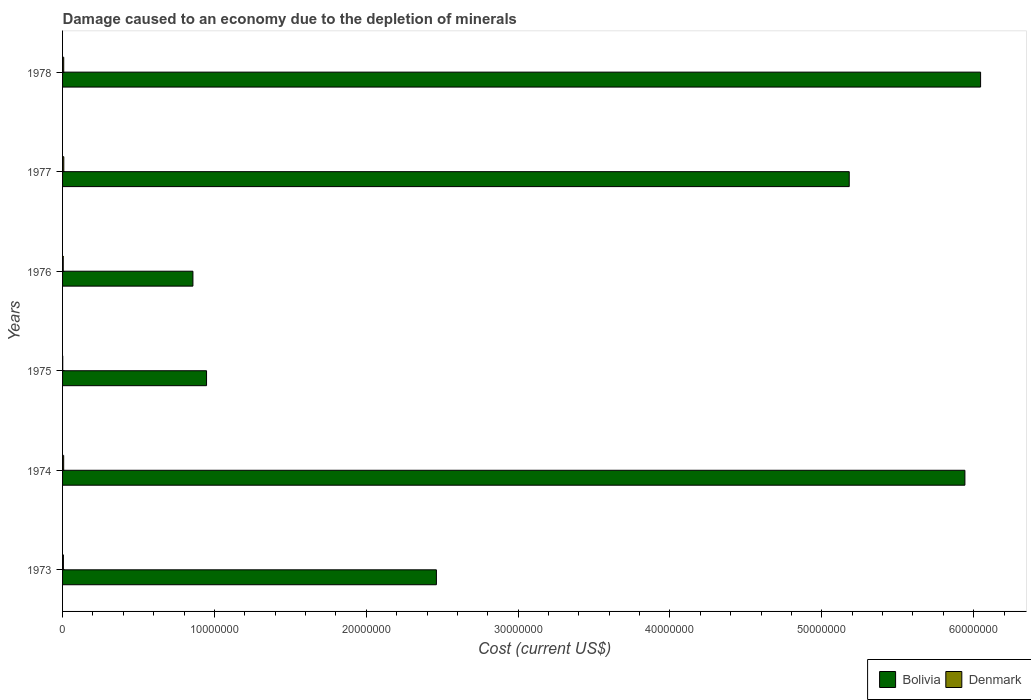How many different coloured bars are there?
Offer a very short reply. 2. How many bars are there on the 5th tick from the top?
Give a very brief answer. 2. What is the label of the 6th group of bars from the top?
Offer a terse response. 1973. What is the cost of damage caused due to the depletion of minerals in Denmark in 1973?
Offer a terse response. 5.65e+04. Across all years, what is the maximum cost of damage caused due to the depletion of minerals in Bolivia?
Ensure brevity in your answer.  6.05e+07. Across all years, what is the minimum cost of damage caused due to the depletion of minerals in Bolivia?
Make the answer very short. 8.58e+06. In which year was the cost of damage caused due to the depletion of minerals in Denmark maximum?
Offer a very short reply. 1977. In which year was the cost of damage caused due to the depletion of minerals in Bolivia minimum?
Ensure brevity in your answer.  1976. What is the total cost of damage caused due to the depletion of minerals in Bolivia in the graph?
Offer a very short reply. 2.14e+08. What is the difference between the cost of damage caused due to the depletion of minerals in Bolivia in 1976 and that in 1977?
Provide a succinct answer. -4.32e+07. What is the difference between the cost of damage caused due to the depletion of minerals in Bolivia in 1978 and the cost of damage caused due to the depletion of minerals in Denmark in 1976?
Give a very brief answer. 6.04e+07. What is the average cost of damage caused due to the depletion of minerals in Denmark per year?
Offer a terse response. 5.70e+04. In the year 1978, what is the difference between the cost of damage caused due to the depletion of minerals in Bolivia and cost of damage caused due to the depletion of minerals in Denmark?
Offer a very short reply. 6.04e+07. In how many years, is the cost of damage caused due to the depletion of minerals in Denmark greater than 34000000 US$?
Your response must be concise. 0. What is the ratio of the cost of damage caused due to the depletion of minerals in Bolivia in 1973 to that in 1975?
Provide a short and direct response. 2.6. Is the cost of damage caused due to the depletion of minerals in Bolivia in 1976 less than that in 1977?
Your response must be concise. Yes. What is the difference between the highest and the second highest cost of damage caused due to the depletion of minerals in Bolivia?
Offer a terse response. 1.03e+06. What is the difference between the highest and the lowest cost of damage caused due to the depletion of minerals in Denmark?
Your answer should be compact. 7.11e+04. Is the sum of the cost of damage caused due to the depletion of minerals in Bolivia in 1974 and 1975 greater than the maximum cost of damage caused due to the depletion of minerals in Denmark across all years?
Your answer should be very brief. Yes. What does the 1st bar from the top in 1973 represents?
Keep it short and to the point. Denmark. What does the 2nd bar from the bottom in 1977 represents?
Make the answer very short. Denmark. How many years are there in the graph?
Your response must be concise. 6. Are the values on the major ticks of X-axis written in scientific E-notation?
Your answer should be compact. No. Does the graph contain any zero values?
Provide a succinct answer. No. Where does the legend appear in the graph?
Your response must be concise. Bottom right. How many legend labels are there?
Offer a very short reply. 2. What is the title of the graph?
Your answer should be compact. Damage caused to an economy due to the depletion of minerals. Does "Low income" appear as one of the legend labels in the graph?
Make the answer very short. No. What is the label or title of the X-axis?
Offer a terse response. Cost (current US$). What is the Cost (current US$) in Bolivia in 1973?
Your answer should be very brief. 2.46e+07. What is the Cost (current US$) of Denmark in 1973?
Give a very brief answer. 5.65e+04. What is the Cost (current US$) in Bolivia in 1974?
Ensure brevity in your answer.  5.94e+07. What is the Cost (current US$) of Denmark in 1974?
Your response must be concise. 7.27e+04. What is the Cost (current US$) of Bolivia in 1975?
Provide a short and direct response. 9.48e+06. What is the Cost (current US$) of Denmark in 1975?
Your response must be concise. 1.03e+04. What is the Cost (current US$) of Bolivia in 1976?
Your answer should be very brief. 8.58e+06. What is the Cost (current US$) in Denmark in 1976?
Ensure brevity in your answer.  4.48e+04. What is the Cost (current US$) in Bolivia in 1977?
Offer a very short reply. 5.18e+07. What is the Cost (current US$) of Denmark in 1977?
Offer a terse response. 8.14e+04. What is the Cost (current US$) in Bolivia in 1978?
Your response must be concise. 6.05e+07. What is the Cost (current US$) of Denmark in 1978?
Give a very brief answer. 7.64e+04. Across all years, what is the maximum Cost (current US$) in Bolivia?
Provide a short and direct response. 6.05e+07. Across all years, what is the maximum Cost (current US$) of Denmark?
Provide a short and direct response. 8.14e+04. Across all years, what is the minimum Cost (current US$) in Bolivia?
Give a very brief answer. 8.58e+06. Across all years, what is the minimum Cost (current US$) in Denmark?
Keep it short and to the point. 1.03e+04. What is the total Cost (current US$) of Bolivia in the graph?
Offer a very short reply. 2.14e+08. What is the total Cost (current US$) in Denmark in the graph?
Your answer should be compact. 3.42e+05. What is the difference between the Cost (current US$) of Bolivia in 1973 and that in 1974?
Provide a short and direct response. -3.48e+07. What is the difference between the Cost (current US$) in Denmark in 1973 and that in 1974?
Your answer should be very brief. -1.62e+04. What is the difference between the Cost (current US$) of Bolivia in 1973 and that in 1975?
Your answer should be very brief. 1.51e+07. What is the difference between the Cost (current US$) of Denmark in 1973 and that in 1975?
Your answer should be very brief. 4.62e+04. What is the difference between the Cost (current US$) in Bolivia in 1973 and that in 1976?
Ensure brevity in your answer.  1.60e+07. What is the difference between the Cost (current US$) in Denmark in 1973 and that in 1976?
Keep it short and to the point. 1.16e+04. What is the difference between the Cost (current US$) of Bolivia in 1973 and that in 1977?
Your answer should be very brief. -2.72e+07. What is the difference between the Cost (current US$) of Denmark in 1973 and that in 1977?
Your answer should be very brief. -2.49e+04. What is the difference between the Cost (current US$) of Bolivia in 1973 and that in 1978?
Your answer should be compact. -3.58e+07. What is the difference between the Cost (current US$) in Denmark in 1973 and that in 1978?
Ensure brevity in your answer.  -1.99e+04. What is the difference between the Cost (current US$) of Bolivia in 1974 and that in 1975?
Make the answer very short. 4.99e+07. What is the difference between the Cost (current US$) in Denmark in 1974 and that in 1975?
Your response must be concise. 6.24e+04. What is the difference between the Cost (current US$) in Bolivia in 1974 and that in 1976?
Give a very brief answer. 5.08e+07. What is the difference between the Cost (current US$) of Denmark in 1974 and that in 1976?
Provide a short and direct response. 2.78e+04. What is the difference between the Cost (current US$) of Bolivia in 1974 and that in 1977?
Your answer should be compact. 7.62e+06. What is the difference between the Cost (current US$) of Denmark in 1974 and that in 1977?
Provide a short and direct response. -8739.33. What is the difference between the Cost (current US$) of Bolivia in 1974 and that in 1978?
Provide a succinct answer. -1.03e+06. What is the difference between the Cost (current US$) in Denmark in 1974 and that in 1978?
Offer a very short reply. -3697.88. What is the difference between the Cost (current US$) in Bolivia in 1975 and that in 1976?
Your response must be concise. 8.97e+05. What is the difference between the Cost (current US$) in Denmark in 1975 and that in 1976?
Offer a terse response. -3.45e+04. What is the difference between the Cost (current US$) in Bolivia in 1975 and that in 1977?
Your answer should be very brief. -4.23e+07. What is the difference between the Cost (current US$) of Denmark in 1975 and that in 1977?
Your response must be concise. -7.11e+04. What is the difference between the Cost (current US$) of Bolivia in 1975 and that in 1978?
Your answer should be compact. -5.10e+07. What is the difference between the Cost (current US$) of Denmark in 1975 and that in 1978?
Your response must be concise. -6.61e+04. What is the difference between the Cost (current US$) in Bolivia in 1976 and that in 1977?
Offer a terse response. -4.32e+07. What is the difference between the Cost (current US$) of Denmark in 1976 and that in 1977?
Offer a terse response. -3.66e+04. What is the difference between the Cost (current US$) in Bolivia in 1976 and that in 1978?
Your answer should be compact. -5.19e+07. What is the difference between the Cost (current US$) in Denmark in 1976 and that in 1978?
Provide a short and direct response. -3.15e+04. What is the difference between the Cost (current US$) of Bolivia in 1977 and that in 1978?
Your response must be concise. -8.65e+06. What is the difference between the Cost (current US$) in Denmark in 1977 and that in 1978?
Keep it short and to the point. 5041.45. What is the difference between the Cost (current US$) of Bolivia in 1973 and the Cost (current US$) of Denmark in 1974?
Offer a very short reply. 2.45e+07. What is the difference between the Cost (current US$) of Bolivia in 1973 and the Cost (current US$) of Denmark in 1975?
Offer a very short reply. 2.46e+07. What is the difference between the Cost (current US$) of Bolivia in 1973 and the Cost (current US$) of Denmark in 1976?
Ensure brevity in your answer.  2.46e+07. What is the difference between the Cost (current US$) in Bolivia in 1973 and the Cost (current US$) in Denmark in 1977?
Ensure brevity in your answer.  2.45e+07. What is the difference between the Cost (current US$) in Bolivia in 1973 and the Cost (current US$) in Denmark in 1978?
Your response must be concise. 2.45e+07. What is the difference between the Cost (current US$) in Bolivia in 1974 and the Cost (current US$) in Denmark in 1975?
Provide a succinct answer. 5.94e+07. What is the difference between the Cost (current US$) in Bolivia in 1974 and the Cost (current US$) in Denmark in 1976?
Give a very brief answer. 5.94e+07. What is the difference between the Cost (current US$) in Bolivia in 1974 and the Cost (current US$) in Denmark in 1977?
Give a very brief answer. 5.93e+07. What is the difference between the Cost (current US$) in Bolivia in 1974 and the Cost (current US$) in Denmark in 1978?
Offer a very short reply. 5.93e+07. What is the difference between the Cost (current US$) of Bolivia in 1975 and the Cost (current US$) of Denmark in 1976?
Offer a terse response. 9.44e+06. What is the difference between the Cost (current US$) in Bolivia in 1975 and the Cost (current US$) in Denmark in 1977?
Keep it short and to the point. 9.40e+06. What is the difference between the Cost (current US$) in Bolivia in 1975 and the Cost (current US$) in Denmark in 1978?
Offer a very short reply. 9.41e+06. What is the difference between the Cost (current US$) in Bolivia in 1976 and the Cost (current US$) in Denmark in 1977?
Give a very brief answer. 8.50e+06. What is the difference between the Cost (current US$) of Bolivia in 1976 and the Cost (current US$) of Denmark in 1978?
Give a very brief answer. 8.51e+06. What is the difference between the Cost (current US$) in Bolivia in 1977 and the Cost (current US$) in Denmark in 1978?
Offer a very short reply. 5.17e+07. What is the average Cost (current US$) of Bolivia per year?
Provide a short and direct response. 3.57e+07. What is the average Cost (current US$) in Denmark per year?
Keep it short and to the point. 5.70e+04. In the year 1973, what is the difference between the Cost (current US$) of Bolivia and Cost (current US$) of Denmark?
Ensure brevity in your answer.  2.46e+07. In the year 1974, what is the difference between the Cost (current US$) of Bolivia and Cost (current US$) of Denmark?
Your answer should be compact. 5.93e+07. In the year 1975, what is the difference between the Cost (current US$) of Bolivia and Cost (current US$) of Denmark?
Your answer should be compact. 9.47e+06. In the year 1976, what is the difference between the Cost (current US$) in Bolivia and Cost (current US$) in Denmark?
Provide a short and direct response. 8.54e+06. In the year 1977, what is the difference between the Cost (current US$) of Bolivia and Cost (current US$) of Denmark?
Your answer should be compact. 5.17e+07. In the year 1978, what is the difference between the Cost (current US$) in Bolivia and Cost (current US$) in Denmark?
Ensure brevity in your answer.  6.04e+07. What is the ratio of the Cost (current US$) in Bolivia in 1973 to that in 1974?
Provide a short and direct response. 0.41. What is the ratio of the Cost (current US$) of Denmark in 1973 to that in 1974?
Your answer should be very brief. 0.78. What is the ratio of the Cost (current US$) in Bolivia in 1973 to that in 1975?
Provide a short and direct response. 2.6. What is the ratio of the Cost (current US$) of Denmark in 1973 to that in 1975?
Keep it short and to the point. 5.49. What is the ratio of the Cost (current US$) of Bolivia in 1973 to that in 1976?
Provide a short and direct response. 2.87. What is the ratio of the Cost (current US$) in Denmark in 1973 to that in 1976?
Your response must be concise. 1.26. What is the ratio of the Cost (current US$) of Bolivia in 1973 to that in 1977?
Give a very brief answer. 0.48. What is the ratio of the Cost (current US$) in Denmark in 1973 to that in 1977?
Ensure brevity in your answer.  0.69. What is the ratio of the Cost (current US$) in Bolivia in 1973 to that in 1978?
Offer a very short reply. 0.41. What is the ratio of the Cost (current US$) of Denmark in 1973 to that in 1978?
Your answer should be compact. 0.74. What is the ratio of the Cost (current US$) of Bolivia in 1974 to that in 1975?
Offer a very short reply. 6.27. What is the ratio of the Cost (current US$) of Denmark in 1974 to that in 1975?
Give a very brief answer. 7.06. What is the ratio of the Cost (current US$) of Bolivia in 1974 to that in 1976?
Your answer should be very brief. 6.92. What is the ratio of the Cost (current US$) of Denmark in 1974 to that in 1976?
Keep it short and to the point. 1.62. What is the ratio of the Cost (current US$) of Bolivia in 1974 to that in 1977?
Make the answer very short. 1.15. What is the ratio of the Cost (current US$) in Denmark in 1974 to that in 1977?
Offer a very short reply. 0.89. What is the ratio of the Cost (current US$) in Bolivia in 1974 to that in 1978?
Provide a succinct answer. 0.98. What is the ratio of the Cost (current US$) of Denmark in 1974 to that in 1978?
Offer a very short reply. 0.95. What is the ratio of the Cost (current US$) in Bolivia in 1975 to that in 1976?
Offer a terse response. 1.1. What is the ratio of the Cost (current US$) of Denmark in 1975 to that in 1976?
Make the answer very short. 0.23. What is the ratio of the Cost (current US$) of Bolivia in 1975 to that in 1977?
Provide a succinct answer. 0.18. What is the ratio of the Cost (current US$) in Denmark in 1975 to that in 1977?
Keep it short and to the point. 0.13. What is the ratio of the Cost (current US$) in Bolivia in 1975 to that in 1978?
Ensure brevity in your answer.  0.16. What is the ratio of the Cost (current US$) in Denmark in 1975 to that in 1978?
Your response must be concise. 0.13. What is the ratio of the Cost (current US$) in Bolivia in 1976 to that in 1977?
Ensure brevity in your answer.  0.17. What is the ratio of the Cost (current US$) in Denmark in 1976 to that in 1977?
Provide a succinct answer. 0.55. What is the ratio of the Cost (current US$) in Bolivia in 1976 to that in 1978?
Offer a very short reply. 0.14. What is the ratio of the Cost (current US$) in Denmark in 1976 to that in 1978?
Keep it short and to the point. 0.59. What is the ratio of the Cost (current US$) in Bolivia in 1977 to that in 1978?
Your answer should be compact. 0.86. What is the ratio of the Cost (current US$) in Denmark in 1977 to that in 1978?
Provide a succinct answer. 1.07. What is the difference between the highest and the second highest Cost (current US$) in Bolivia?
Your response must be concise. 1.03e+06. What is the difference between the highest and the second highest Cost (current US$) in Denmark?
Offer a very short reply. 5041.45. What is the difference between the highest and the lowest Cost (current US$) of Bolivia?
Offer a terse response. 5.19e+07. What is the difference between the highest and the lowest Cost (current US$) of Denmark?
Provide a short and direct response. 7.11e+04. 